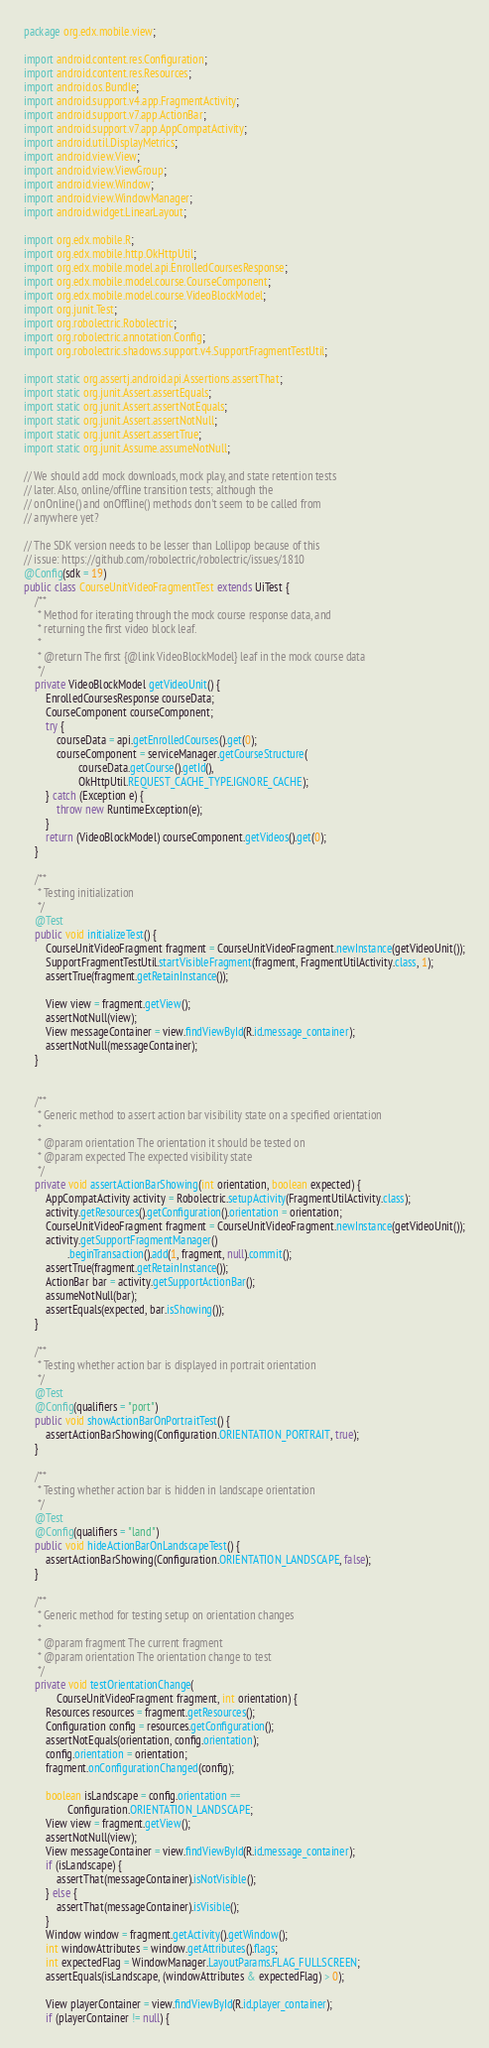<code> <loc_0><loc_0><loc_500><loc_500><_Java_>package org.edx.mobile.view;

import android.content.res.Configuration;
import android.content.res.Resources;
import android.os.Bundle;
import android.support.v4.app.FragmentActivity;
import android.support.v7.app.ActionBar;
import android.support.v7.app.AppCompatActivity;
import android.util.DisplayMetrics;
import android.view.View;
import android.view.ViewGroup;
import android.view.Window;
import android.view.WindowManager;
import android.widget.LinearLayout;

import org.edx.mobile.R;
import org.edx.mobile.http.OkHttpUtil;
import org.edx.mobile.model.api.EnrolledCoursesResponse;
import org.edx.mobile.model.course.CourseComponent;
import org.edx.mobile.model.course.VideoBlockModel;
import org.junit.Test;
import org.robolectric.Robolectric;
import org.robolectric.annotation.Config;
import org.robolectric.shadows.support.v4.SupportFragmentTestUtil;

import static org.assertj.android.api.Assertions.assertThat;
import static org.junit.Assert.assertEquals;
import static org.junit.Assert.assertNotEquals;
import static org.junit.Assert.assertNotNull;
import static org.junit.Assert.assertTrue;
import static org.junit.Assume.assumeNotNull;

// We should add mock downloads, mock play, and state retention tests
// later. Also, online/offline transition tests; although the
// onOnline() and onOffline() methods don't seem to be called from
// anywhere yet?

// The SDK version needs to be lesser than Lollipop because of this
// issue: https://github.com/robolectric/robolectric/issues/1810
@Config(sdk = 19)
public class CourseUnitVideoFragmentTest extends UiTest {
    /**
     * Method for iterating through the mock course response data, and
     * returning the first video block leaf.
     *
     * @return The first {@link VideoBlockModel} leaf in the mock course data
     */
    private VideoBlockModel getVideoUnit() {
        EnrolledCoursesResponse courseData;
        CourseComponent courseComponent;
        try {
            courseData = api.getEnrolledCourses().get(0);
            courseComponent = serviceManager.getCourseStructure(
                    courseData.getCourse().getId(),
                    OkHttpUtil.REQUEST_CACHE_TYPE.IGNORE_CACHE);
        } catch (Exception e) {
            throw new RuntimeException(e);
        }
        return (VideoBlockModel) courseComponent.getVideos().get(0);
    }

    /**
     * Testing initialization
     */
    @Test
    public void initializeTest() {
        CourseUnitVideoFragment fragment = CourseUnitVideoFragment.newInstance(getVideoUnit());
        SupportFragmentTestUtil.startVisibleFragment(fragment, FragmentUtilActivity.class, 1);
        assertTrue(fragment.getRetainInstance());

        View view = fragment.getView();
        assertNotNull(view);
        View messageContainer = view.findViewById(R.id.message_container);
        assertNotNull(messageContainer);
    }


    /**
     * Generic method to assert action bar visibility state on a specified orientation
     *
     * @param orientation The orientation it should be tested on
     * @param expected The expected visibility state
     */
    private void assertActionBarShowing(int orientation, boolean expected) {
        AppCompatActivity activity = Robolectric.setupActivity(FragmentUtilActivity.class);
        activity.getResources().getConfiguration().orientation = orientation;
        CourseUnitVideoFragment fragment = CourseUnitVideoFragment.newInstance(getVideoUnit());
        activity.getSupportFragmentManager()
                .beginTransaction().add(1, fragment, null).commit();
        assertTrue(fragment.getRetainInstance());
        ActionBar bar = activity.getSupportActionBar();
        assumeNotNull(bar);
        assertEquals(expected, bar.isShowing());
    }

    /**
     * Testing whether action bar is displayed in portrait orientation
     */
    @Test
    @Config(qualifiers = "port")
    public void showActionBarOnPortraitTest() {
        assertActionBarShowing(Configuration.ORIENTATION_PORTRAIT, true);
    }

    /**
     * Testing whether action bar is hidden in landscape orientation
     */
    @Test
    @Config(qualifiers = "land")
    public void hideActionBarOnLandscapeTest() {
        assertActionBarShowing(Configuration.ORIENTATION_LANDSCAPE, false);
    }

    /**
     * Generic method for testing setup on orientation changes
     *
     * @param fragment The current fragment
     * @param orientation The orientation change to test
     */
    private void testOrientationChange(
            CourseUnitVideoFragment fragment, int orientation) {
        Resources resources = fragment.getResources();
        Configuration config = resources.getConfiguration();
        assertNotEquals(orientation, config.orientation);
        config.orientation = orientation;
        fragment.onConfigurationChanged(config);

        boolean isLandscape = config.orientation ==
                Configuration.ORIENTATION_LANDSCAPE;
        View view = fragment.getView();
        assertNotNull(view);
        View messageContainer = view.findViewById(R.id.message_container);
        if (isLandscape) {
            assertThat(messageContainer).isNotVisible();
        } else {
            assertThat(messageContainer).isVisible();
        }
        Window window = fragment.getActivity().getWindow();
        int windowAttributes = window.getAttributes().flags;
        int expectedFlag = WindowManager.LayoutParams.FLAG_FULLSCREEN;
        assertEquals(isLandscape, (windowAttributes & expectedFlag) > 0);

        View playerContainer = view.findViewById(R.id.player_container);
        if (playerContainer != null) {</code> 